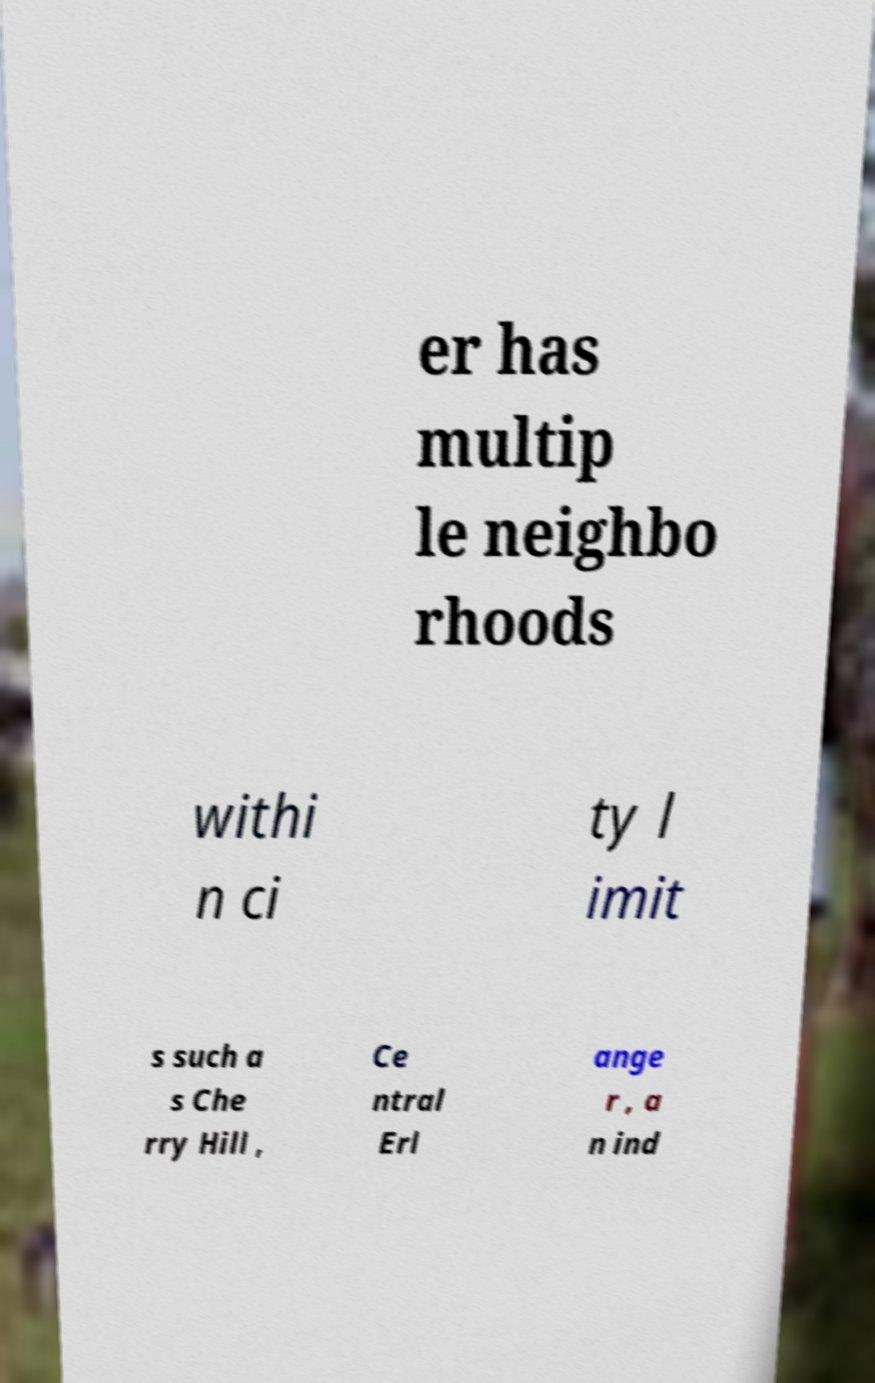What messages or text are displayed in this image? I need them in a readable, typed format. er has multip le neighbo rhoods withi n ci ty l imit s such a s Che rry Hill , Ce ntral Erl ange r , a n ind 